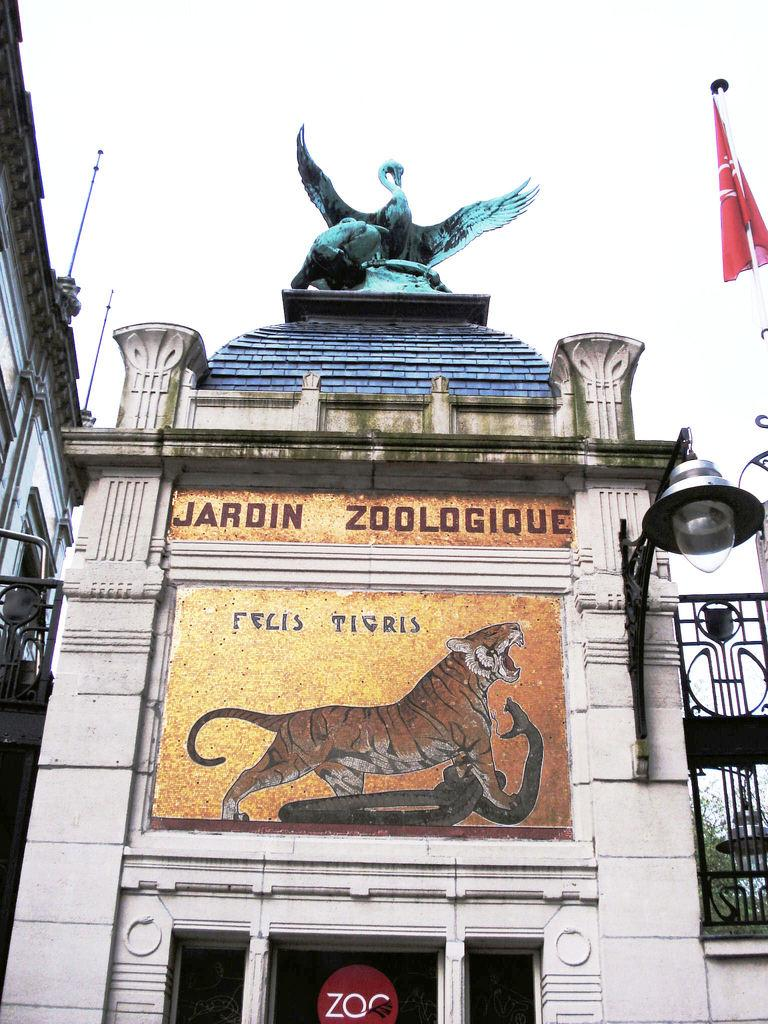What type of structures can be seen in the image? There are buildings in the image. What artistic feature is present in the image? There is a sculpture in the image. What is the source of illumination in the image? There is light in the image. What signage is visible in the image? There is a name board in the image. What type of entrance is depicted in the image? There is a gate in the image. What type of decorative or symbolic objects are present in the image? There are flags in the image. What type of vertical supports are present in the image? There are poles in the image. What other objects can be seen in the image? There are other objects in the image. What can be seen in the background of the image? The sky is visible in the background of the image. How many dogs are sitting on the poles in the image? There are no dogs present in the image. What type of can is being used to hold the flags in the image? There is no can present in the image; the flags are attached to poles. 